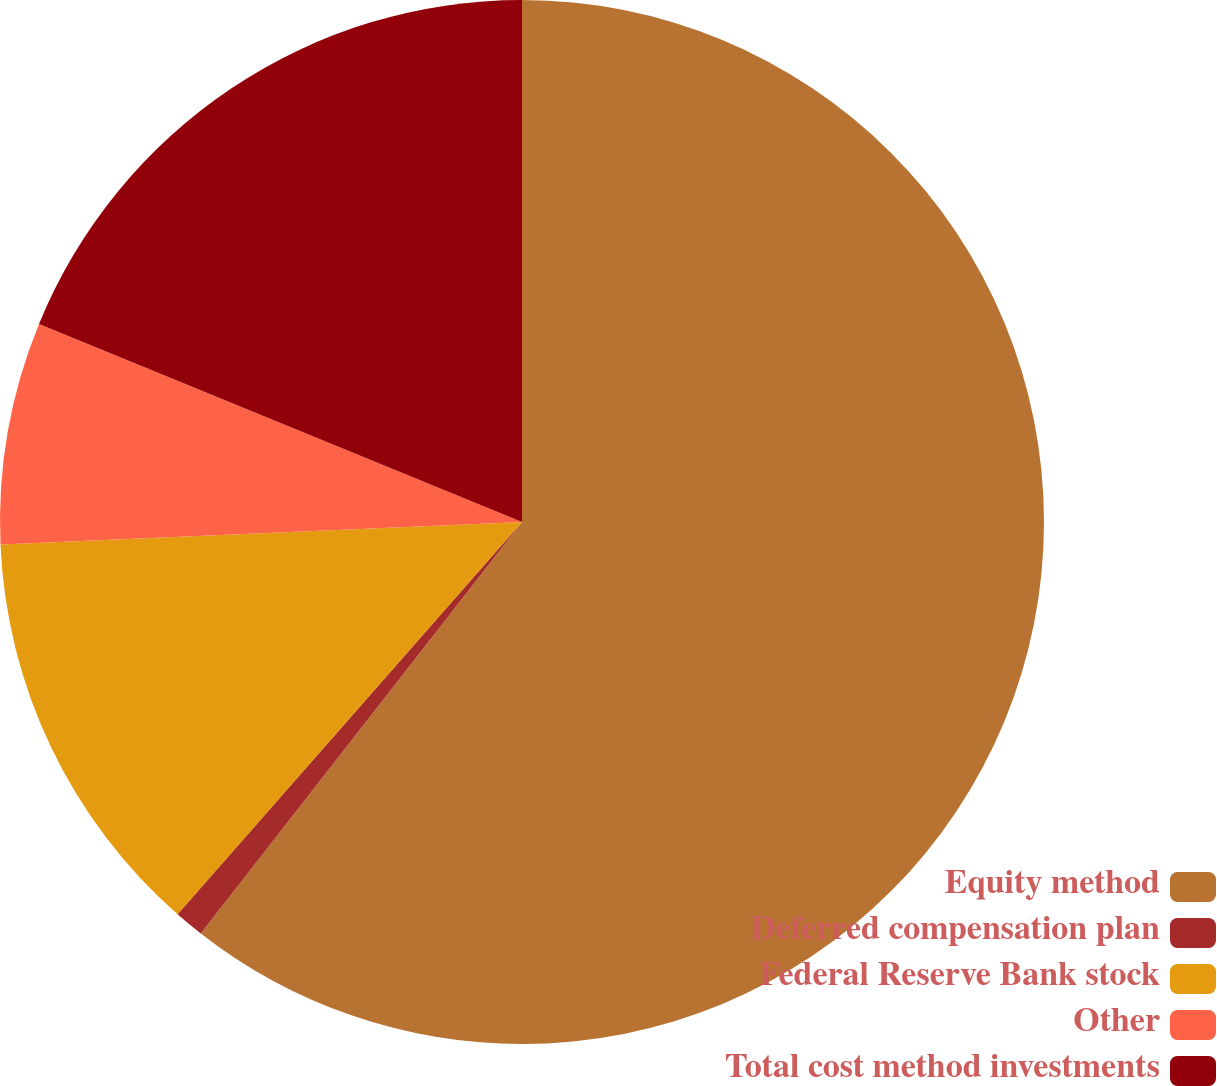<chart> <loc_0><loc_0><loc_500><loc_500><pie_chart><fcel>Equity method<fcel>Deferred compensation plan<fcel>Federal Reserve Bank stock<fcel>Other<fcel>Total cost method investments<nl><fcel>60.55%<fcel>0.92%<fcel>12.84%<fcel>6.88%<fcel>18.81%<nl></chart> 